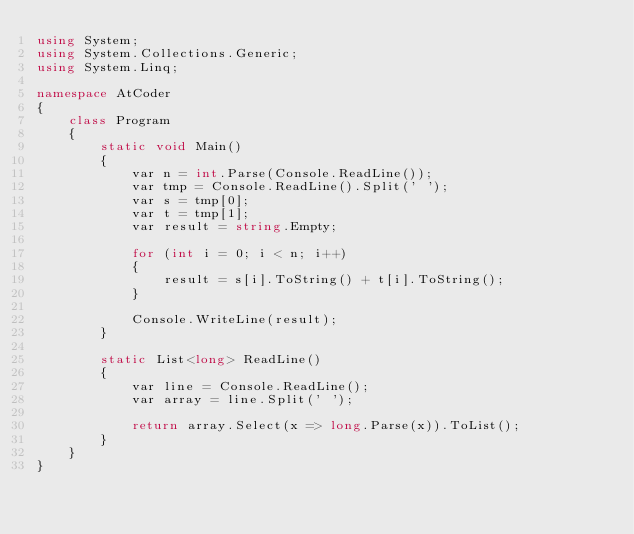Convert code to text. <code><loc_0><loc_0><loc_500><loc_500><_C#_>using System;
using System.Collections.Generic;
using System.Linq;

namespace AtCoder
{
    class Program
    {
        static void Main()
        {
            var n = int.Parse(Console.ReadLine());
            var tmp = Console.ReadLine().Split(' ');
            var s = tmp[0];
            var t = tmp[1];
            var result = string.Empty;

            for (int i = 0; i < n; i++)
            {
                result = s[i].ToString() + t[i].ToString();
            }

            Console.WriteLine(result);
        }

        static List<long> ReadLine()
        {
            var line = Console.ReadLine();
            var array = line.Split(' ');

            return array.Select(x => long.Parse(x)).ToList();
        }
    }
}</code> 